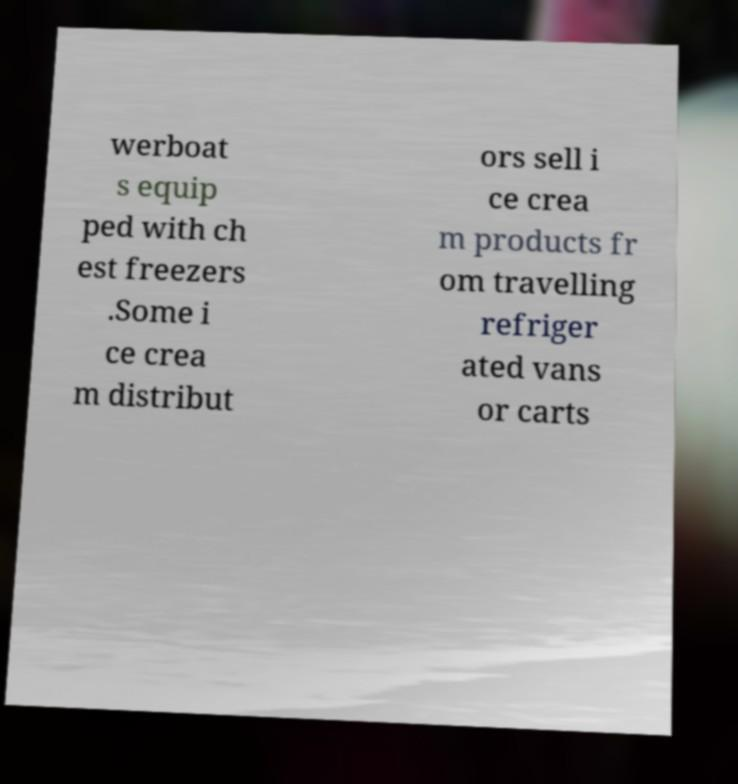I need the written content from this picture converted into text. Can you do that? werboat s equip ped with ch est freezers .Some i ce crea m distribut ors sell i ce crea m products fr om travelling refriger ated vans or carts 